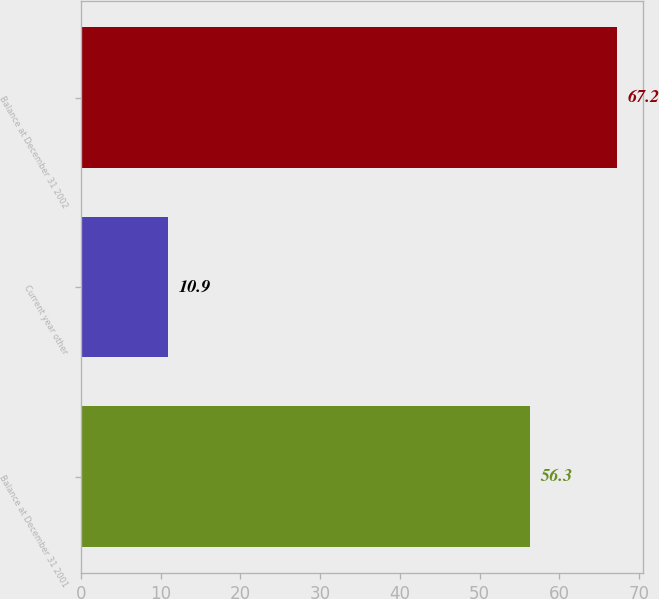Convert chart. <chart><loc_0><loc_0><loc_500><loc_500><bar_chart><fcel>Balance at December 31 2001<fcel>Current year other<fcel>Balance at December 31 2002<nl><fcel>56.3<fcel>10.9<fcel>67.2<nl></chart> 